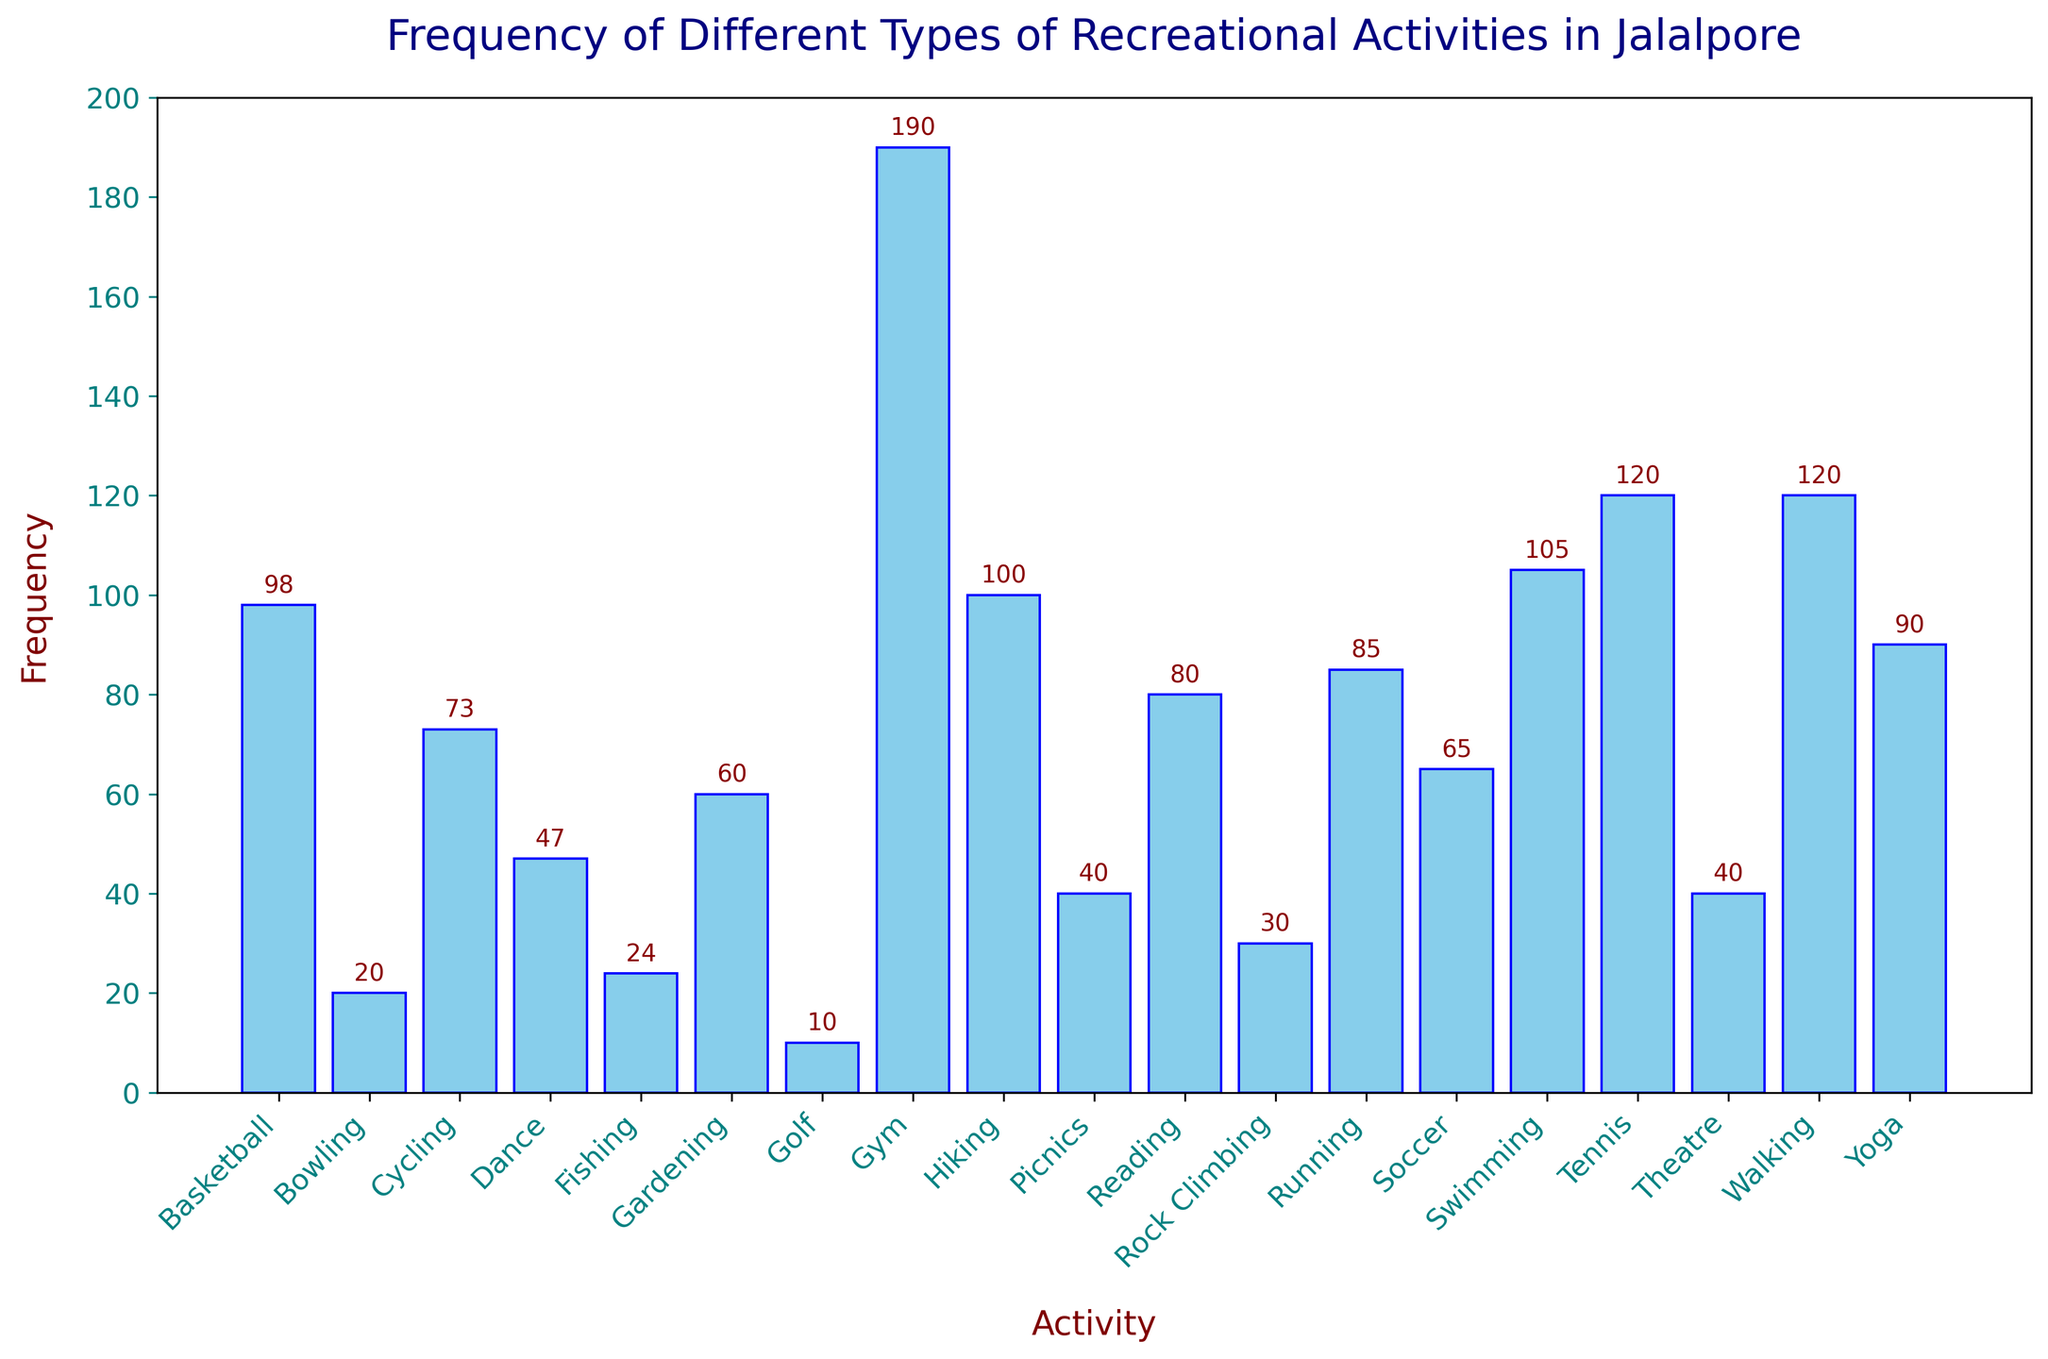Which activity has the highest frequency? The activity with the highest bar represents the highest frequency. The 'Gym' bar is the tallest.
Answer: Gym Which two activities have the same frequency? Look for bars with the same height and label. Both 'Yoga' bars have the same height.
Answer: Yoga How many more people participate in walking compared to rock climbing? Find the height of the 'Walking' and 'Rock Climbing' bars and determine the difference. 120 (Walking) - 15 (Rock Climbing) = 105.
Answer: 105 What is the total frequency of all activities combined? Sum the frequencies of all activities. The frequency values from the plot are added together: 120+85+73+50+45+40+30+28+25+22+20+15+12+50+45+150+90+70+40+25+20+15+12+50+55+20+10+80+60+40 = 1452.
Answer: 1452 Is Running more or less popular than Cycling, and by how much? Compare the heights of the 'Running' and 'Cycling' bars and find the difference. 85 (Running) - 73 (Cycling) = 12.
Answer: More, by 12 Which activity has the lowest frequency? The shortest bar represents the lowest frequency. The 'Golf' bar is the shortest.
Answer: Golf How does the frequency of Soccer compare to that of Basketball? Compare the heights of the 'Soccer' and 'Basketball' bars. Basketball is taller than Soccer.
Answer: Basketball is more frequent than Soccer What is the combined frequency of Swimming and Hiking? Add the frequencies of 'Swimming' (50) and 'Hiking' (50). 50 + 50 = 100.
Answer: 100 Are there more people participating in Running or Reading? Compare the heights of the 'Running' and 'Reading' bars. The reading bar is shorter.
Answer: Running What is the average frequency of the top three most frequent activities? Identify the three tallest bars ('Gym' 150, 'Walking' 120, 'Tennis' 90) and calculate their average. (150 + 120 + 90) / 3 = 360 / 3 = 120.
Answer: 120 